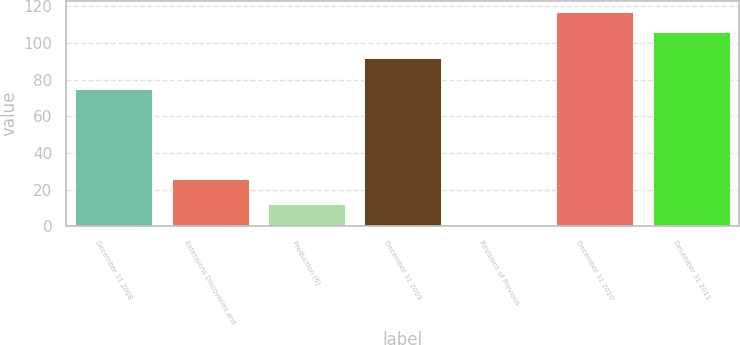<chart> <loc_0><loc_0><loc_500><loc_500><bar_chart><fcel>December 31 2008<fcel>Extensions Discoveries and<fcel>Production (6)<fcel>December 31 2009<fcel>Revisions of Previous<fcel>December 31 2010<fcel>December 31 2011<nl><fcel>75<fcel>26<fcel>12.1<fcel>92<fcel>1<fcel>117.1<fcel>106<nl></chart> 